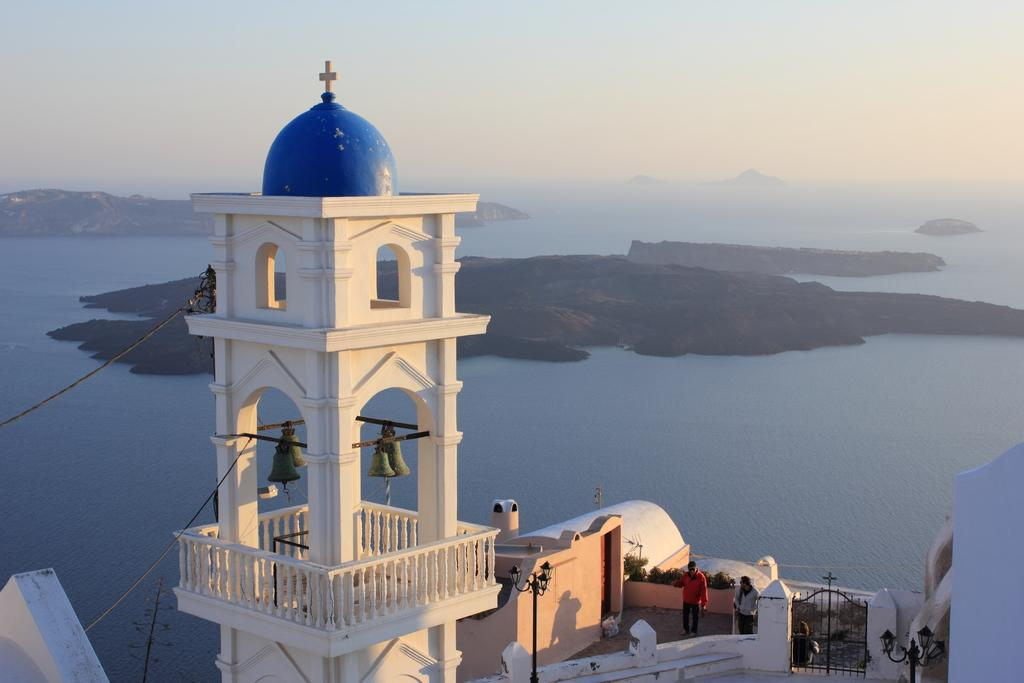What type of building is in the foreground of the image? There is a church in the foreground of the image. Can you describe the people in the image? There are people in the image, but their specific actions or characteristics are not mentioned in the provided facts. What can be seen in the background of the image? There are mountains, water, and the sky visible in the background of the image. What type of bait is being used by the people in the image? There is no mention of fishing or bait in the provided facts, so we cannot answer this question. 